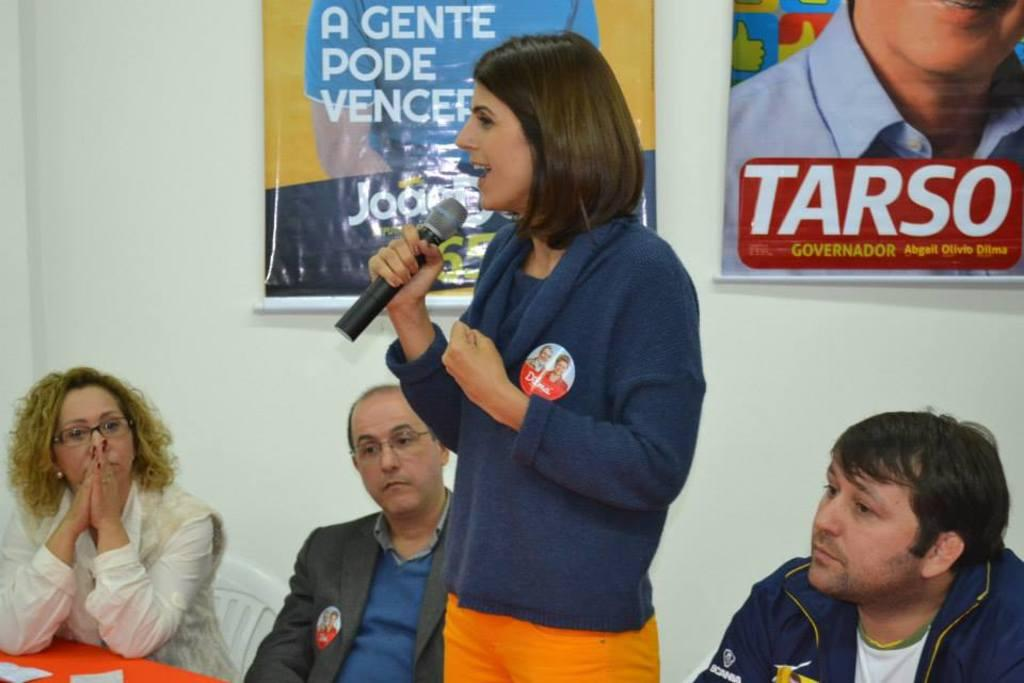Who is the main subject in the image? There is a woman in the image. What is the woman doing in the image? The woman is standing and speaking. What tool is the woman using to amplify her voice? The woman is using a microphone. What are the people in the image doing? The people are seated in the image. What can be seen on the wall in the image? There are posters on the wall. Can you see a crown on the woman's head in the image? No, there is no crown visible on the woman's head in the image. What type of yoke is being used by the people in the image? There is no yoke present in the image; it is a gathering of people with a woman speaking using a microphone. 